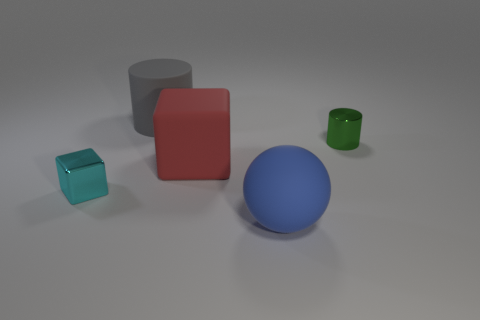Add 2 small cyan blocks. How many objects exist? 7 Subtract all blocks. How many objects are left? 3 Subtract 0 yellow blocks. How many objects are left? 5 Subtract all big red cubes. Subtract all cylinders. How many objects are left? 2 Add 2 cyan metal blocks. How many cyan metal blocks are left? 3 Add 5 tiny cyan blocks. How many tiny cyan blocks exist? 6 